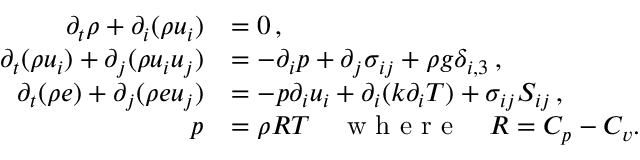Convert formula to latex. <formula><loc_0><loc_0><loc_500><loc_500>\begin{array} { r l } { \partial _ { t } \rho + \partial _ { i } ( \rho u _ { i } ) } & { = 0 \, , } \\ { \partial _ { t } ( \rho u _ { i } ) + \partial _ { j } ( \rho u _ { i } u _ { j } ) } & { = - \partial _ { i } p + \partial _ { j } \sigma _ { i j } + \rho g \delta _ { i , 3 } \, , } \\ { \partial _ { t } ( \rho e ) + \partial _ { j } ( \rho e u _ { j } ) } & { = - p \partial _ { i } u _ { i } + \partial _ { i } ( k \partial _ { i } T ) + \sigma _ { i j } S _ { i j } \, , } \\ { p } & { = \rho R T \quad w h e r e \quad R = C _ { p } - C _ { v } . } \end{array}</formula> 